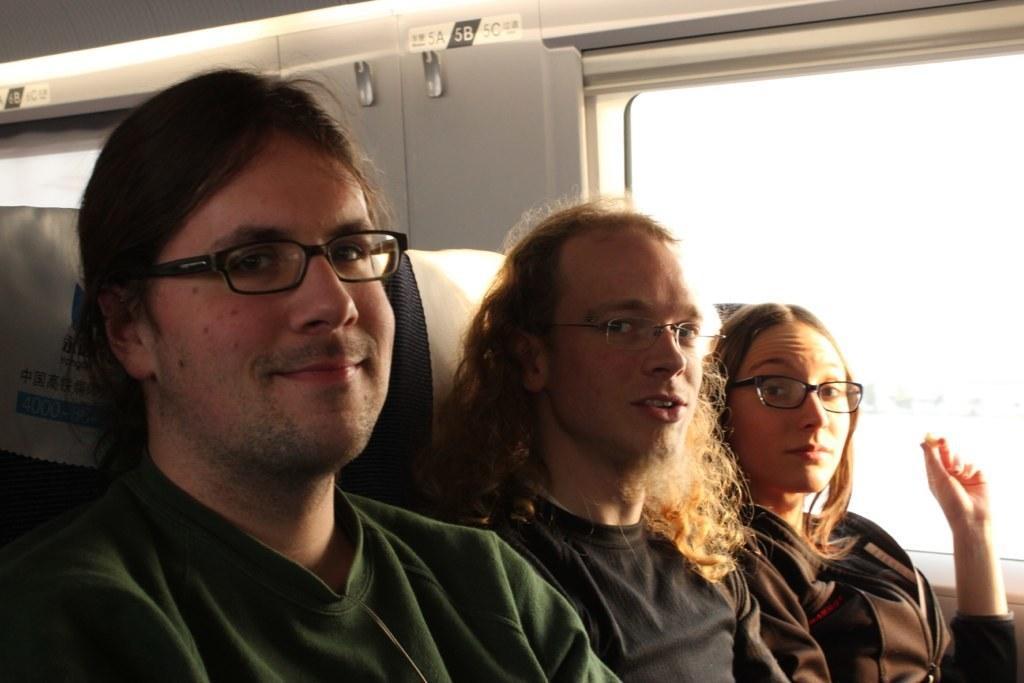Please provide a concise description of this image. In the center of the image we can see three people sitting in the vehicle. On the right there is a window. 